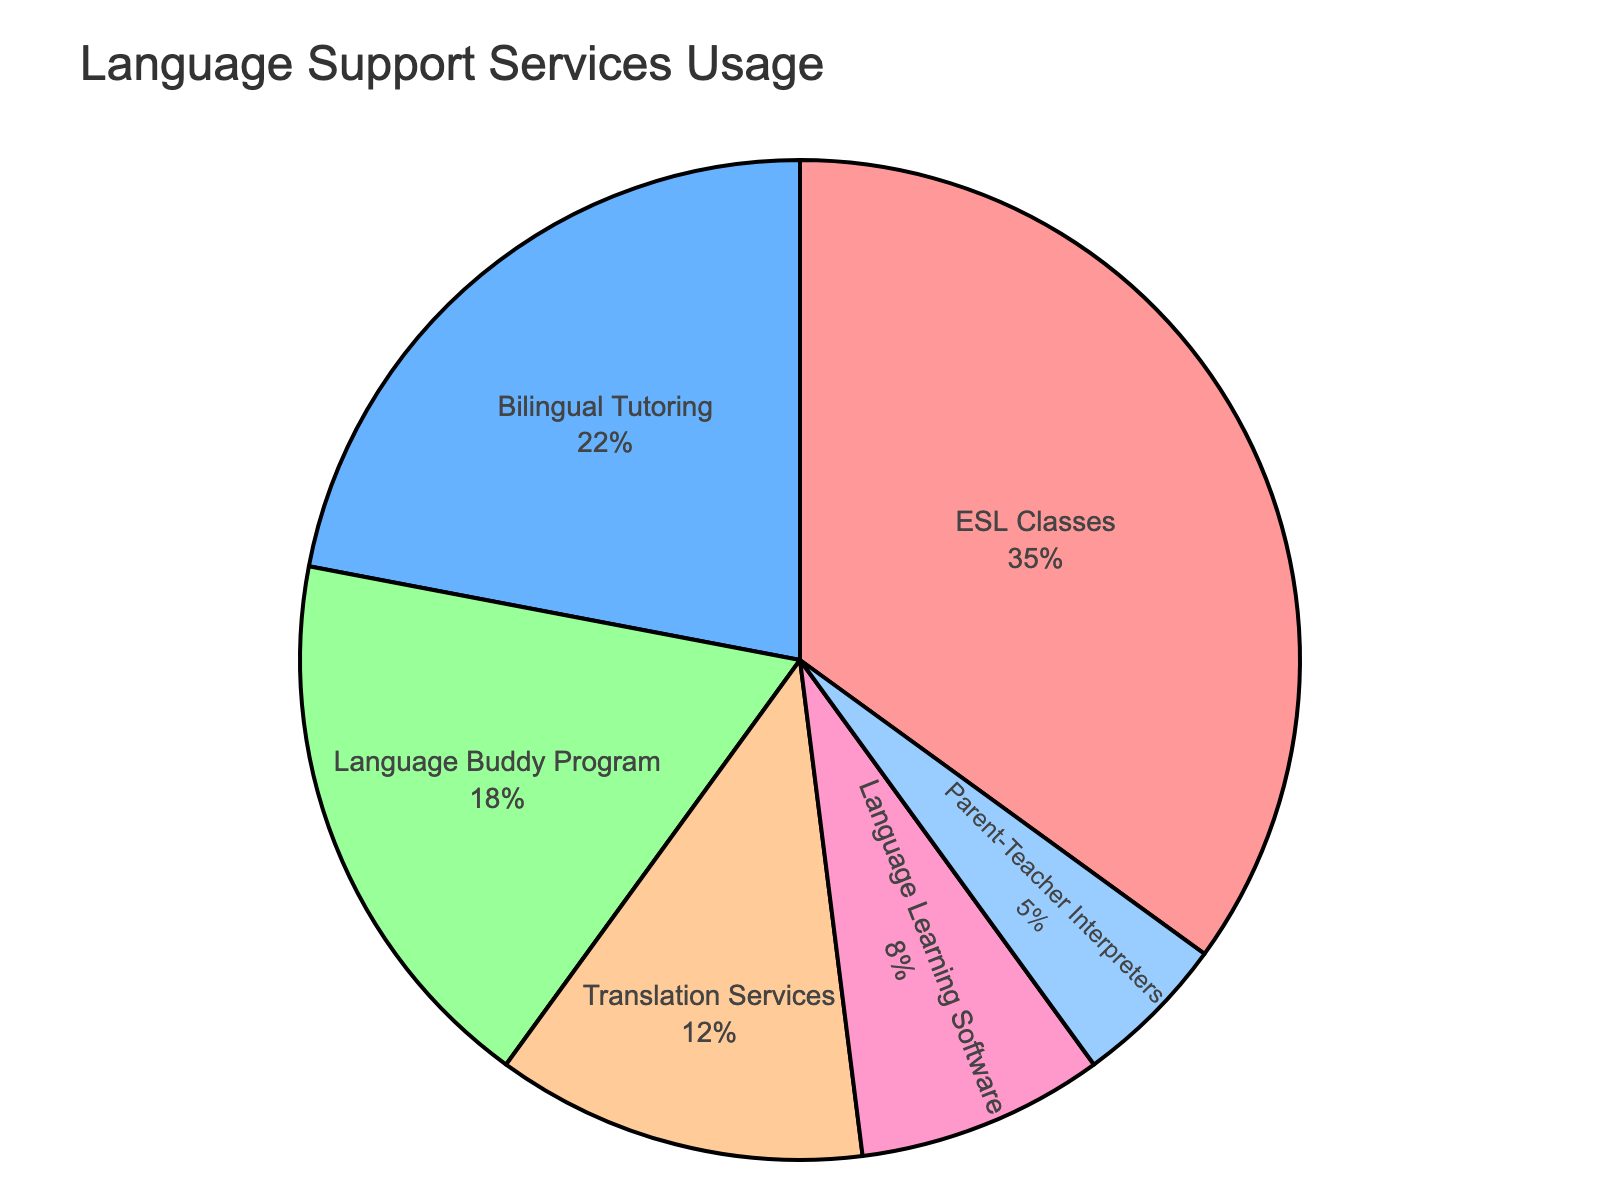Which language support service has the highest usage rate? The pie chart shows the usage rates of various language support services. The largest segment, representing 35%, corresponds to ESL Classes.
Answer: ESL Classes Which two services have the smallest usage rates, and what are their combined percentages? The pie chart segments for Translation Services and Parent-Teacher Interpreters are the smallest, representing 12% and 5%, respectively. Adding these gives 12% + 5% = 17%.
Answer: Translation Services and Parent-Teacher Interpreters, 17% Compare the usage rate of the Bilingual Tutoring service to the Language Buddy Program. Which is higher and by how much? The usage rate for Bilingual Tutoring is 22%, and for the Language Buddy Program, it is 18%. The difference is 22% - 18% = 4%.
Answer: Bilingual Tutoring by 4% What percentage of the total usage do ESL Classes and Bilingual Tutoring together make up? ESL Classes have a usage rate of 35%, and Bilingual Tutoring has 22%. Adding these gives 35% + 22% = 57%.
Answer: 57% How does the usage rate of Language Learning Software compare to Translation Services? The usage rate for Language Learning Software is 8%, while for Translation Services, it is 12%. Translation Services have a higher usage rate, with a difference of 12% - 8% = 4%.
Answer: Translation Services by 4% What fraction of the total usage is contributed by Parent-Teacher Interpreters? Parent-Teacher Interpreters have a usage rate of 5%. Given that the pie chart represents total usage as 100%, the fraction is 5/100, which simplifies to 1/20.
Answer: 1/20 If the school decided to increase the usage of Language Learning Software by 10 percentage points, what would its new usage rate be? The current usage rate of Language Learning Software is 8%. Adding 10 percentage points gives 8% + 10% = 18%.
Answer: 18% What is the combined usage rate of all services except ESL Classes? Summing the usage rates of all services except ESL Classes: Bilingual Tutoring 22%, Language Buddy Program 18%, Translation Services 12%, Language Learning Software 8%, Parent-Teacher Interpreters 5%. The total is 22% + 18% + 12% + 8% + 5% = 65%.
Answer: 65% 